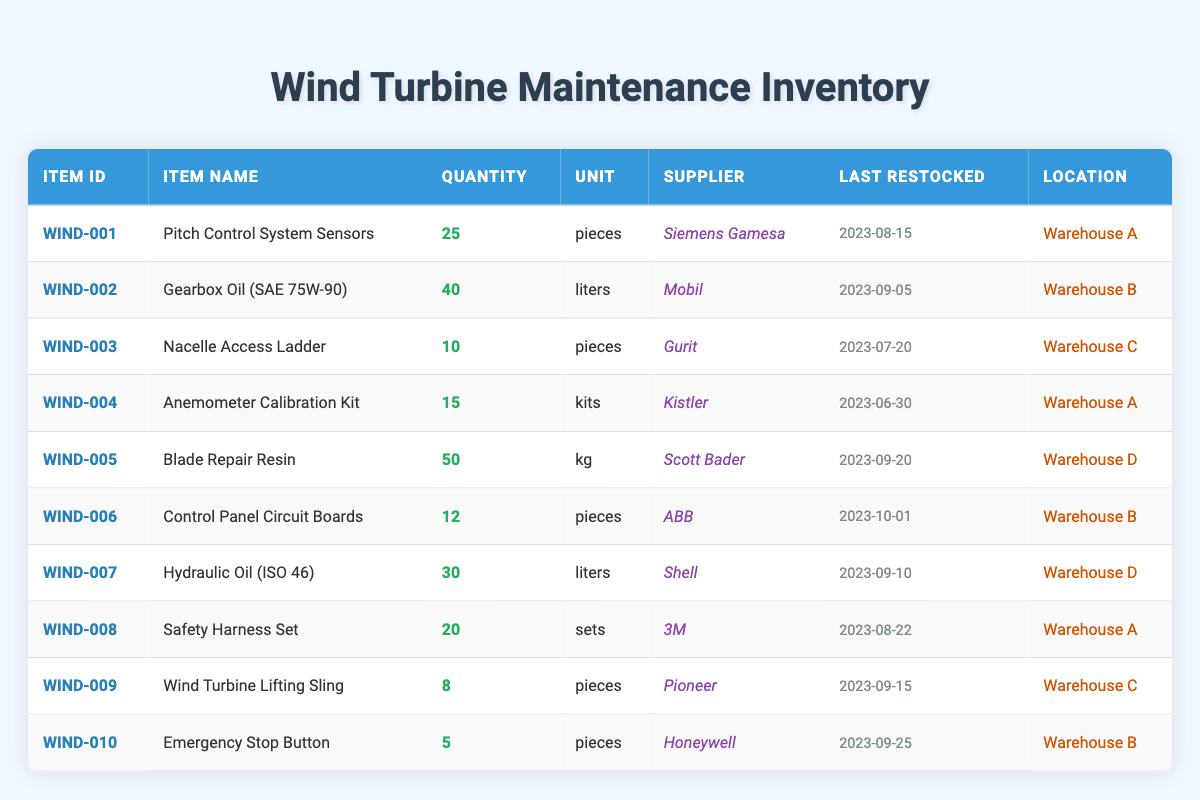What's the quantity of Gearbox Oil (SAE 75W-90)? By scanning the table, I find "Gearbox Oil (SAE 75W-90)" under the "Item Name" column, and the corresponding "Quantity" is 40.
Answer: 40 How many Safety Harness Sets are available? Looking at the "Item Name" for "Safety Harness Set," the quantity listed in the "Quantity" column is 20.
Answer: 20 Which item has the highest quantity in stock? By comparing the quantities in the "Quantity" column, "Blade Repair Resin" has the highest quantity at 50, while the others have less than that.
Answer: Blade Repair Resin What is the total quantity of hydraulic supplies (Gearbox Oil and Hydraulic Oil)? The quantity of Gearbox Oil is 40 liters and the quantity of Hydraulic Oil is 30 liters. Adding these together gives: 40 + 30 = 70.
Answer: 70 Which supplier provided Nacelle Access Ladder? According to the table, the supplier listed next to "Nacelle Access Ladder" is "Gurit."
Answer: Gurit Is there any item in stock that was last restocked in August 2023? By checking the "Last Restocked" column, I see that "Pitch Control System Sensors," "Safety Harness Set," and "Gearbox Oil" were all restocked in August 2023. Thus, the answer is yes.
Answer: Yes What is the average quantity of the items restocked in September? The items restocked in September are Gearbox Oil (40), Hydraulic Oil (30), Blade Repair Resin (50), Emergency Stop Button (5), and the total quantity is 40 + 30 + 50 + 5 = 125. Dividing by the number of items (4) gives an average of 125 / 4 = 31.25.
Answer: 31.25 How many more pieces of Pitch Control System Sensors are available compared to Wind Turbine Lifting Sling? Pitch Control System Sensors have 25 pieces, while Wind Turbine Lifting Sling has 8 pieces. Thus, the difference is 25 - 8 = 17 pieces.
Answer: 17 What is the total quantity of items stored in Warehouse B? The items listed for Warehouse B are Gearbox Oil (40), Control Panel Circuit Boards (12), and Emergency Stop Button (5). Adding these quantities gives 40 + 12 + 5 = 57.
Answer: 57 